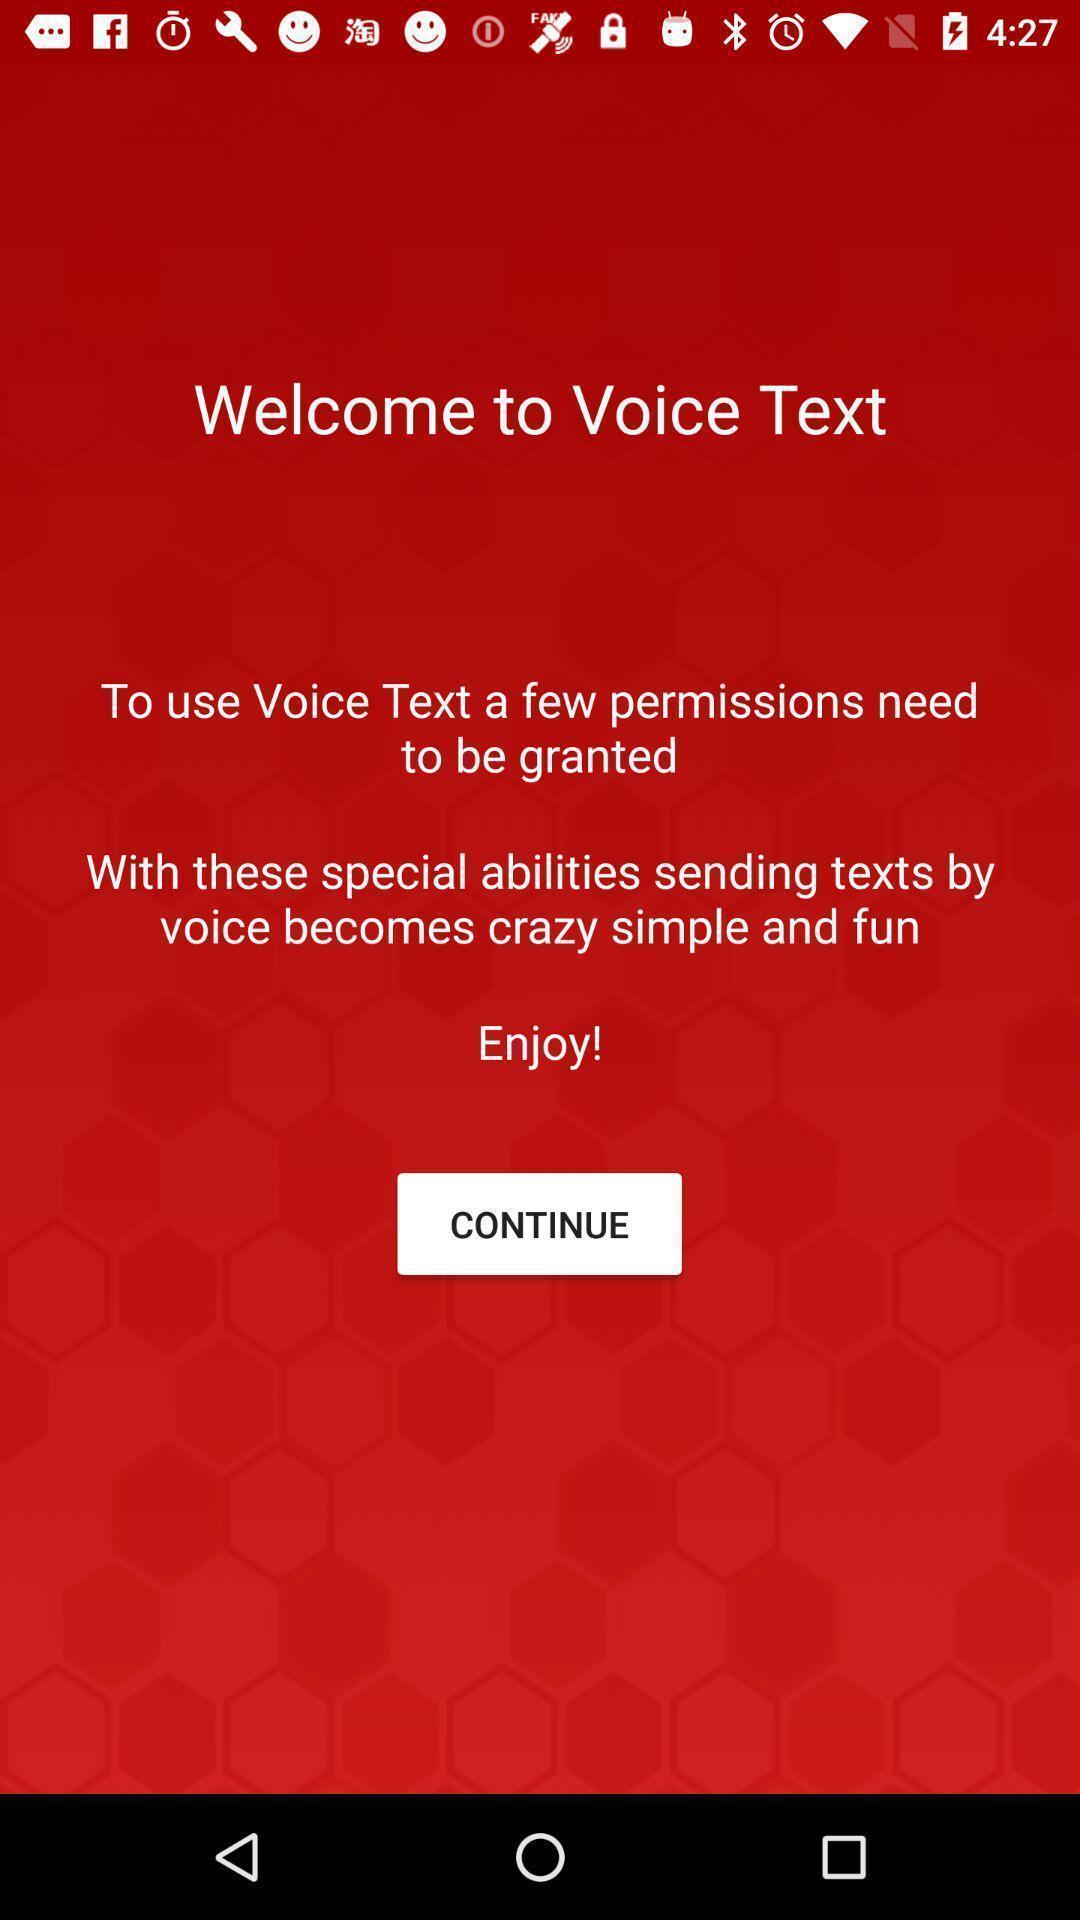What details can you identify in this image? Welcome screen with permissions. 